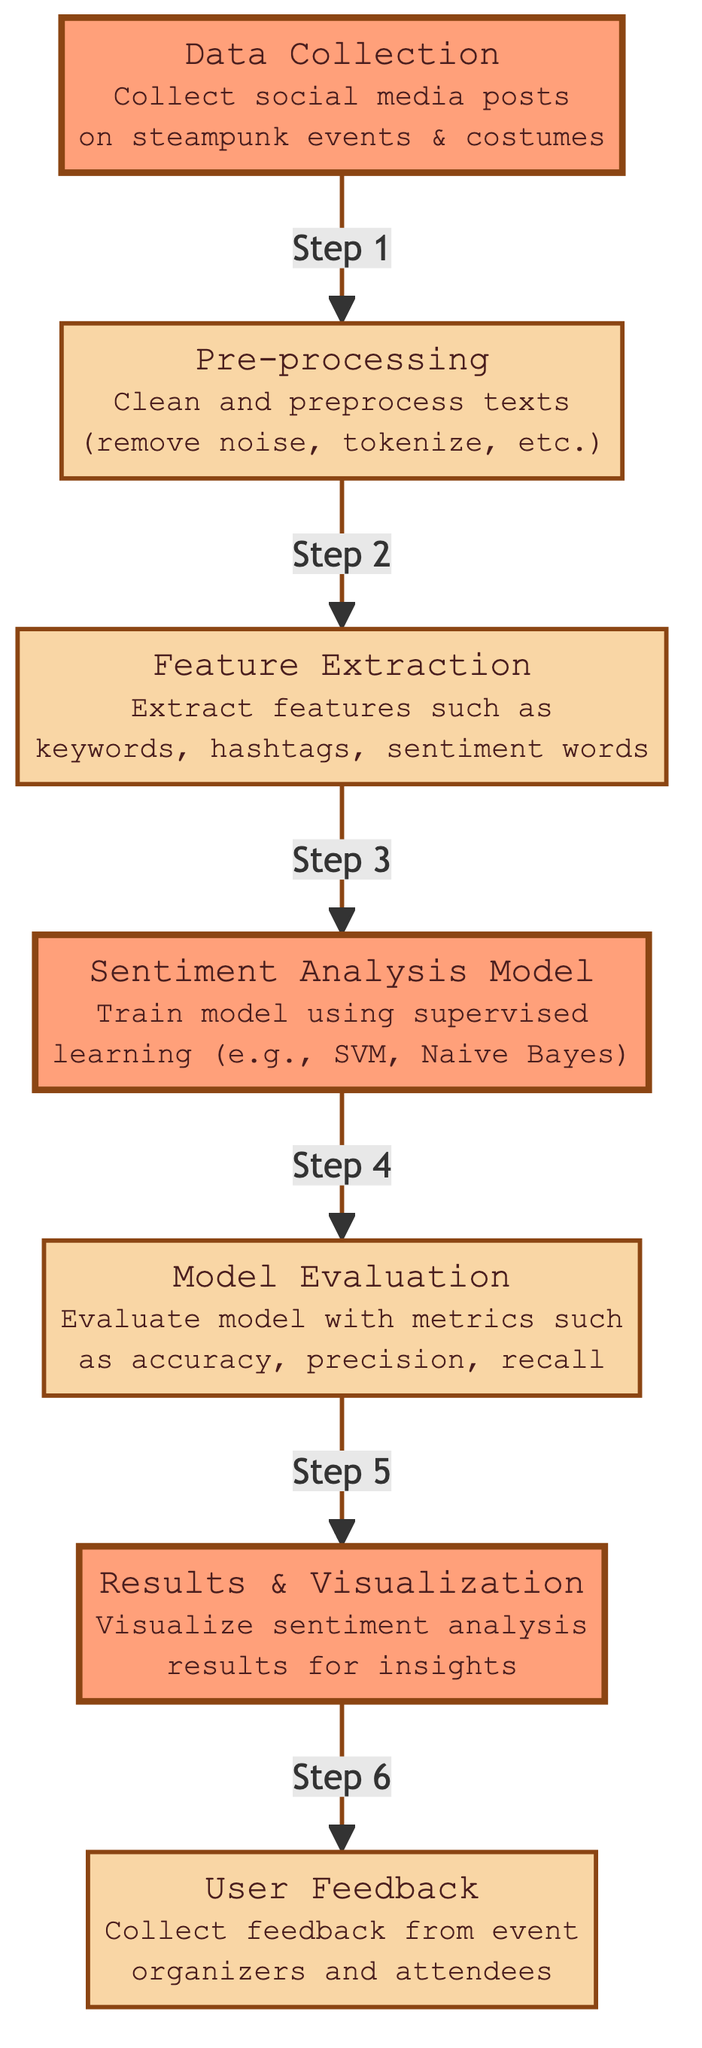What is the first step in the diagram? The first step in the diagram is "Data Collection," which indicates that social media posts related to steampunk events and costumes are gathered as the initial action.
Answer: Data Collection How many nodes are in the diagram? The diagram consists of a total of seven nodes, each representing a different step in the sentiment analysis process.
Answer: Seven What connects "Feature Extraction" to "Sentiment Analysis Model"? "Feature Extraction" connects to "Sentiment Analysis Model" as a sequential step in the process where the extracted features are fed into the model.
Answer: Sequential connection Which node has the process of “clean and preprocess texts”? The node that includes the process of “clean and preprocess texts” is "Pre-processing," which details the actions taken to prepare the data for analysis.
Answer: Pre-processing What is the relationship between "Model Evaluation" and "Results & Visualization"? "Model Evaluation" precedes "Results & Visualization"; evaluation is necessary to understand how well the model performed before visualizing the insights gained.
Answer: Precedes Which models are mentioned for training in "Sentiment Analysis Model"? The models mentioned for training in the "Sentiment Analysis Model" node include supervised learning techniques such as SVM and Naive Bayes.
Answer: SVM, Naive Bayes Which node indicates the collection of feedback from users? The node that indicates the collection of feedback from users is "User Feedback," which represents the final step in the process focusing on gathering input from event organizers and attendees.
Answer: User Feedback What is the main focus of “Results & Visualization”? The main focus of "Results & Visualization" is to visualize the results of sentiment analysis to draw insights about social media sentiment concerning steampunk events and costumes.
Answer: Visualize sentiment analysis results What are the metrics used in "Model Evaluation"? The metrics used in "Model Evaluation" include accuracy, precision, and recall, which assess the model's performance in analyzing sentiment.
Answer: Accuracy, precision, recall 